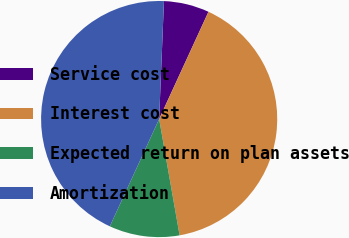Convert chart. <chart><loc_0><loc_0><loc_500><loc_500><pie_chart><fcel>Service cost<fcel>Interest cost<fcel>Expected return on plan assets<fcel>Amortization<nl><fcel>6.21%<fcel>40.37%<fcel>9.63%<fcel>43.79%<nl></chart> 